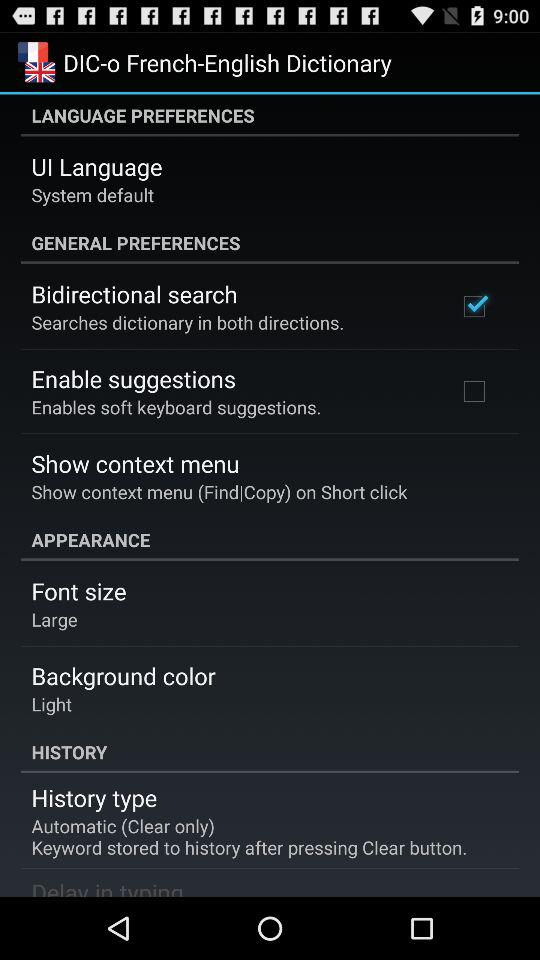What is the status of the "Bidirectional Search"? The status is "on". 